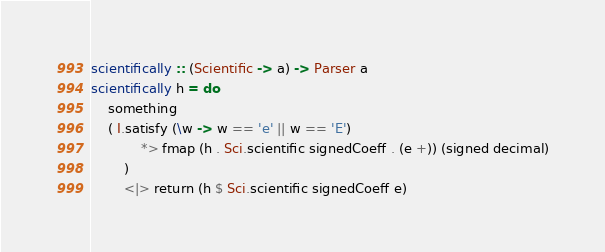<code> <loc_0><loc_0><loc_500><loc_500><_Haskell_>scientifically :: (Scientific -> a) -> Parser a
scientifically h = do
    something
    ( I.satisfy (\w -> w == 'e' || w == 'E')
            *> fmap (h . Sci.scientific signedCoeff . (e +)) (signed decimal)
        )
        <|> return (h $ Sci.scientific signedCoeff e)
</code> 